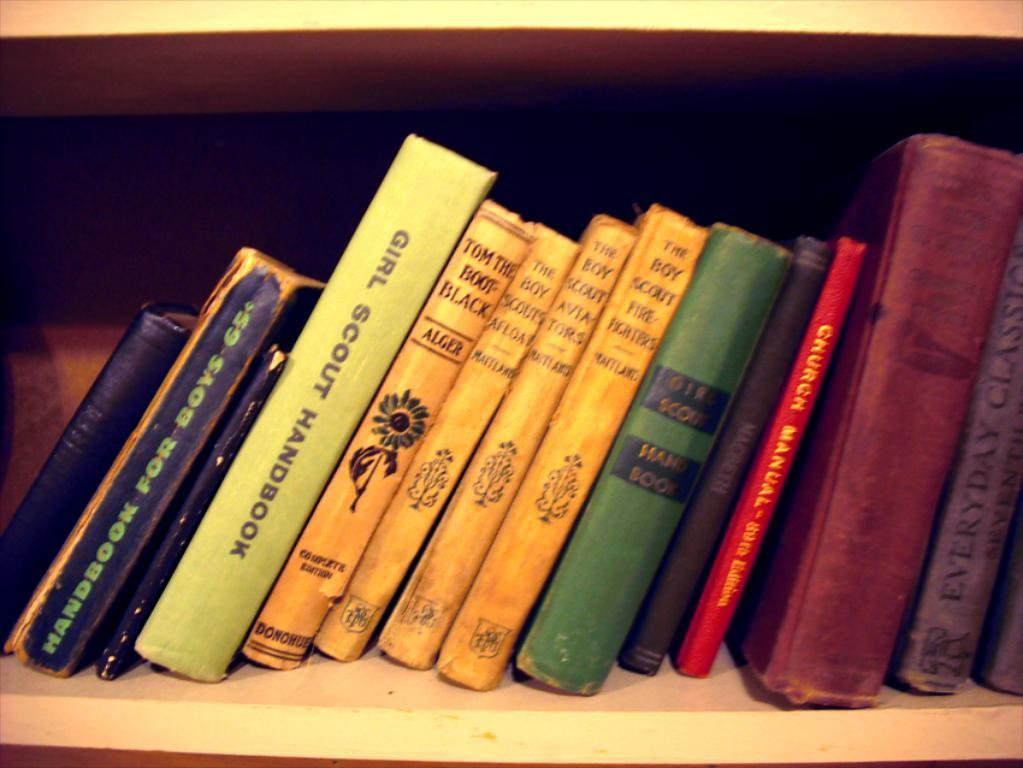What objects can be seen in the image? There are books in the image. How are the books organized in the image? The books are arranged in a rack. What song is being played on the fifth book in the image? There is no information about a song or any music being played in the image. Additionally, there is no mention of a fifth book or any specific book in the provided facts. 